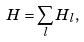Convert formula to latex. <formula><loc_0><loc_0><loc_500><loc_500>H = \sum _ { l } H _ { l } , \\</formula> 